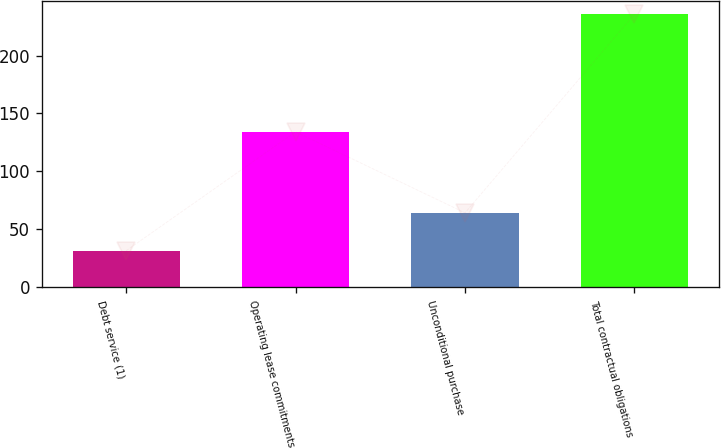Convert chart. <chart><loc_0><loc_0><loc_500><loc_500><bar_chart><fcel>Debt service (1)<fcel>Operating lease commitments<fcel>Unconditional purchase<fcel>Total contractual obligations<nl><fcel>31.6<fcel>134.2<fcel>64.3<fcel>235.6<nl></chart> 